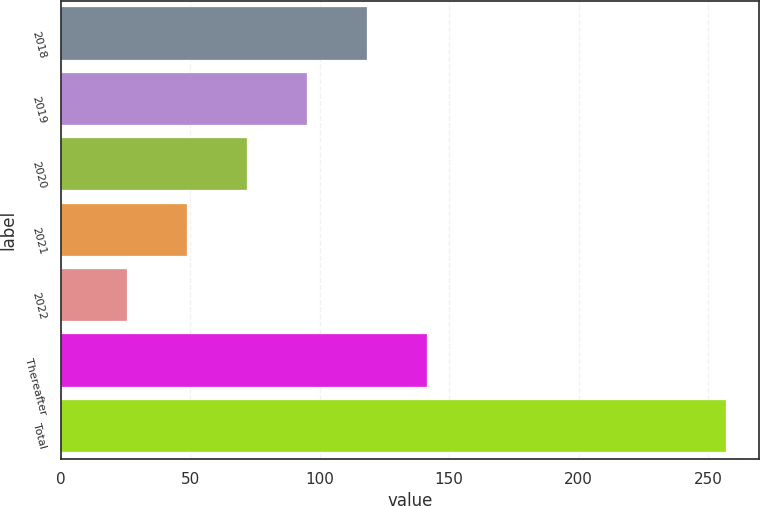Convert chart. <chart><loc_0><loc_0><loc_500><loc_500><bar_chart><fcel>2018<fcel>2019<fcel>2020<fcel>2021<fcel>2022<fcel>Thereafter<fcel>Total<nl><fcel>118.18<fcel>95.06<fcel>71.94<fcel>48.82<fcel>25.7<fcel>141.3<fcel>256.9<nl></chart> 